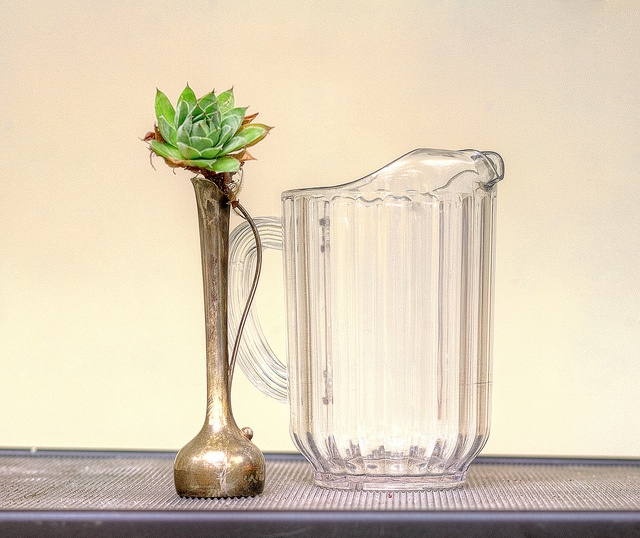Describe the objects in this image and their specific colors. I can see cup in lightgray, beige, tan, and darkgray tones, potted plant in lightgray, tan, beige, and gray tones, and vase in lightgray, tan, beige, and gray tones in this image. 